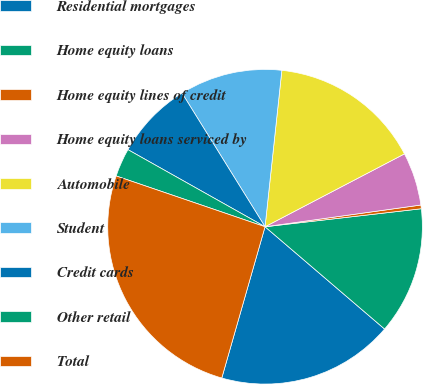<chart> <loc_0><loc_0><loc_500><loc_500><pie_chart><fcel>Residential mortgages<fcel>Home equity loans<fcel>Home equity lines of credit<fcel>Home equity loans serviced by<fcel>Automobile<fcel>Student<fcel>Credit cards<fcel>Other retail<fcel>Total<nl><fcel>18.17%<fcel>13.09%<fcel>0.38%<fcel>5.46%<fcel>15.63%<fcel>10.55%<fcel>8.0%<fcel>2.92%<fcel>25.8%<nl></chart> 